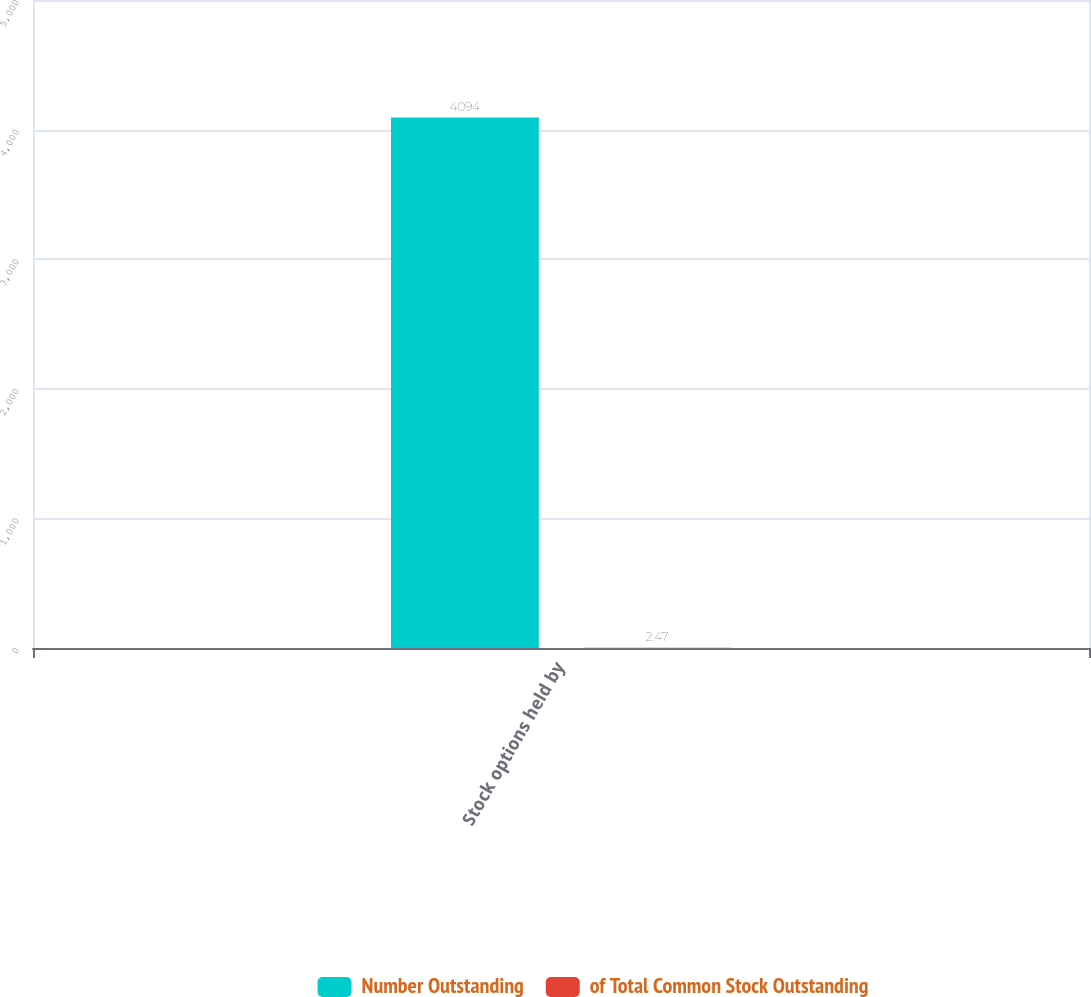Convert chart to OTSL. <chart><loc_0><loc_0><loc_500><loc_500><stacked_bar_chart><ecel><fcel>Stock options held by<nl><fcel>Number Outstanding<fcel>4094<nl><fcel>of Total Common Stock Outstanding<fcel>2.47<nl></chart> 